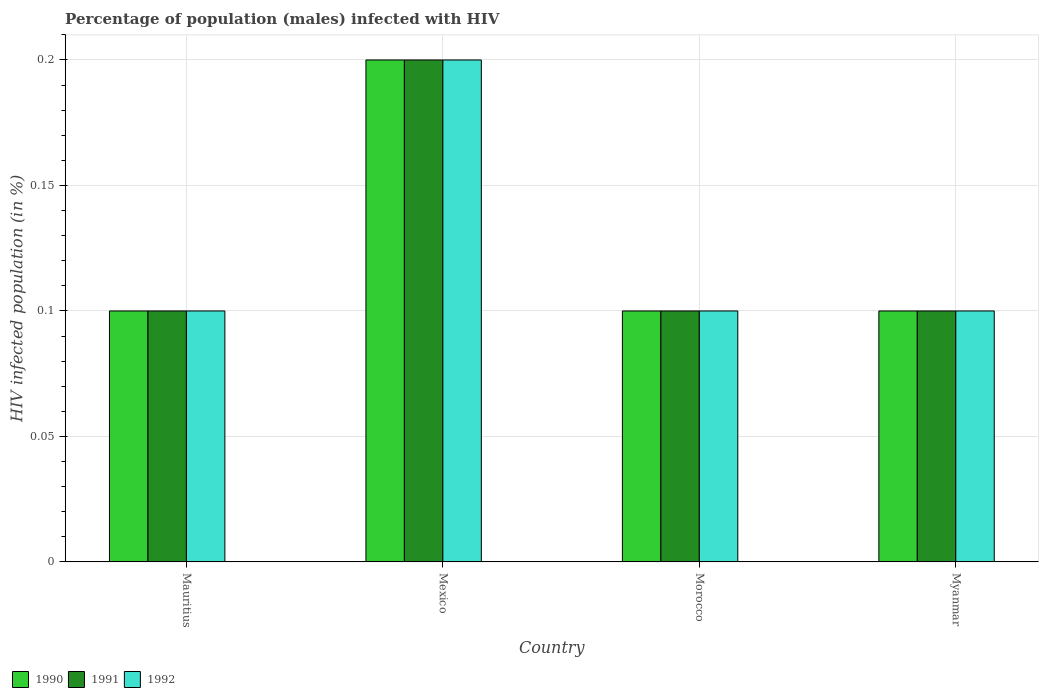How many different coloured bars are there?
Offer a very short reply. 3. How many groups of bars are there?
Keep it short and to the point. 4. Are the number of bars per tick equal to the number of legend labels?
Provide a succinct answer. Yes. How many bars are there on the 2nd tick from the left?
Make the answer very short. 3. How many bars are there on the 2nd tick from the right?
Your response must be concise. 3. What is the label of the 1st group of bars from the left?
Your response must be concise. Mauritius. In which country was the percentage of HIV infected male population in 1992 maximum?
Your response must be concise. Mexico. In which country was the percentage of HIV infected male population in 1990 minimum?
Your answer should be compact. Mauritius. Is the difference between the percentage of HIV infected male population in 1992 in Mauritius and Morocco greater than the difference between the percentage of HIV infected male population in 1991 in Mauritius and Morocco?
Make the answer very short. No. What is the difference between the highest and the second highest percentage of HIV infected male population in 1992?
Ensure brevity in your answer.  0.1. What is the difference between the highest and the lowest percentage of HIV infected male population in 1991?
Your response must be concise. 0.1. Is the sum of the percentage of HIV infected male population in 1990 in Mauritius and Morocco greater than the maximum percentage of HIV infected male population in 1992 across all countries?
Your answer should be very brief. No. What does the 3rd bar from the right in Mauritius represents?
Offer a very short reply. 1990. Is it the case that in every country, the sum of the percentage of HIV infected male population in 1991 and percentage of HIV infected male population in 1990 is greater than the percentage of HIV infected male population in 1992?
Provide a short and direct response. Yes. How many bars are there?
Provide a succinct answer. 12. Are the values on the major ticks of Y-axis written in scientific E-notation?
Provide a succinct answer. No. Does the graph contain grids?
Provide a succinct answer. Yes. How are the legend labels stacked?
Your answer should be compact. Horizontal. What is the title of the graph?
Ensure brevity in your answer.  Percentage of population (males) infected with HIV. Does "2010" appear as one of the legend labels in the graph?
Give a very brief answer. No. What is the label or title of the X-axis?
Your answer should be compact. Country. What is the label or title of the Y-axis?
Your answer should be very brief. HIV infected population (in %). What is the HIV infected population (in %) in 1990 in Mauritius?
Give a very brief answer. 0.1. What is the HIV infected population (in %) in 1991 in Mauritius?
Your answer should be compact. 0.1. What is the HIV infected population (in %) of 1992 in Mauritius?
Offer a terse response. 0.1. What is the HIV infected population (in %) of 1991 in Mexico?
Ensure brevity in your answer.  0.2. What is the HIV infected population (in %) in 1992 in Mexico?
Provide a succinct answer. 0.2. What is the HIV infected population (in %) of 1992 in Morocco?
Make the answer very short. 0.1. What is the HIV infected population (in %) of 1990 in Myanmar?
Offer a very short reply. 0.1. Across all countries, what is the minimum HIV infected population (in %) in 1990?
Make the answer very short. 0.1. Across all countries, what is the minimum HIV infected population (in %) in 1991?
Your answer should be very brief. 0.1. Across all countries, what is the minimum HIV infected population (in %) of 1992?
Provide a short and direct response. 0.1. What is the total HIV infected population (in %) of 1992 in the graph?
Provide a short and direct response. 0.5. What is the difference between the HIV infected population (in %) of 1991 in Mauritius and that in Mexico?
Your response must be concise. -0.1. What is the difference between the HIV infected population (in %) in 1992 in Mauritius and that in Morocco?
Your response must be concise. 0. What is the difference between the HIV infected population (in %) of 1990 in Mexico and that in Morocco?
Your answer should be compact. 0.1. What is the difference between the HIV infected population (in %) of 1992 in Mexico and that in Morocco?
Offer a terse response. 0.1. What is the difference between the HIV infected population (in %) in 1990 in Mexico and that in Myanmar?
Your response must be concise. 0.1. What is the difference between the HIV infected population (in %) in 1991 in Mexico and that in Myanmar?
Provide a succinct answer. 0.1. What is the difference between the HIV infected population (in %) of 1992 in Mexico and that in Myanmar?
Provide a succinct answer. 0.1. What is the difference between the HIV infected population (in %) of 1991 in Morocco and that in Myanmar?
Ensure brevity in your answer.  0. What is the difference between the HIV infected population (in %) of 1992 in Morocco and that in Myanmar?
Ensure brevity in your answer.  0. What is the difference between the HIV infected population (in %) in 1990 in Mauritius and the HIV infected population (in %) in 1992 in Mexico?
Make the answer very short. -0.1. What is the difference between the HIV infected population (in %) in 1990 in Mauritius and the HIV infected population (in %) in 1991 in Morocco?
Offer a terse response. 0. What is the difference between the HIV infected population (in %) in 1991 in Mauritius and the HIV infected population (in %) in 1992 in Morocco?
Offer a very short reply. 0. What is the difference between the HIV infected population (in %) of 1990 in Mauritius and the HIV infected population (in %) of 1992 in Myanmar?
Your answer should be very brief. 0. What is the difference between the HIV infected population (in %) of 1991 in Mauritius and the HIV infected population (in %) of 1992 in Myanmar?
Ensure brevity in your answer.  0. What is the difference between the HIV infected population (in %) in 1990 in Mexico and the HIV infected population (in %) in 1991 in Morocco?
Offer a very short reply. 0.1. What is the difference between the HIV infected population (in %) of 1990 in Mexico and the HIV infected population (in %) of 1992 in Morocco?
Give a very brief answer. 0.1. What is the difference between the HIV infected population (in %) of 1990 in Morocco and the HIV infected population (in %) of 1992 in Myanmar?
Keep it short and to the point. 0. What is the difference between the HIV infected population (in %) in 1991 in Morocco and the HIV infected population (in %) in 1992 in Myanmar?
Provide a short and direct response. 0. What is the average HIV infected population (in %) in 1990 per country?
Your answer should be compact. 0.12. What is the average HIV infected population (in %) in 1991 per country?
Your answer should be very brief. 0.12. What is the average HIV infected population (in %) in 1992 per country?
Your answer should be compact. 0.12. What is the difference between the HIV infected population (in %) of 1990 and HIV infected population (in %) of 1991 in Mauritius?
Provide a short and direct response. 0. What is the difference between the HIV infected population (in %) of 1990 and HIV infected population (in %) of 1992 in Mauritius?
Offer a very short reply. 0. What is the difference between the HIV infected population (in %) in 1991 and HIV infected population (in %) in 1992 in Mauritius?
Your response must be concise. 0. What is the difference between the HIV infected population (in %) of 1990 and HIV infected population (in %) of 1991 in Mexico?
Your response must be concise. 0. What is the difference between the HIV infected population (in %) of 1990 and HIV infected population (in %) of 1992 in Morocco?
Make the answer very short. 0. What is the difference between the HIV infected population (in %) of 1991 and HIV infected population (in %) of 1992 in Morocco?
Keep it short and to the point. 0. What is the ratio of the HIV infected population (in %) of 1990 in Mauritius to that in Mexico?
Give a very brief answer. 0.5. What is the ratio of the HIV infected population (in %) of 1992 in Mauritius to that in Mexico?
Your answer should be very brief. 0.5. What is the ratio of the HIV infected population (in %) in 1991 in Mauritius to that in Morocco?
Make the answer very short. 1. What is the ratio of the HIV infected population (in %) of 1990 in Mauritius to that in Myanmar?
Provide a succinct answer. 1. What is the ratio of the HIV infected population (in %) in 1991 in Mauritius to that in Myanmar?
Offer a very short reply. 1. What is the ratio of the HIV infected population (in %) of 1992 in Mauritius to that in Myanmar?
Make the answer very short. 1. What is the ratio of the HIV infected population (in %) in 1990 in Mexico to that in Morocco?
Provide a succinct answer. 2. What is the ratio of the HIV infected population (in %) in 1991 in Mexico to that in Morocco?
Your answer should be very brief. 2. What is the ratio of the HIV infected population (in %) in 1991 in Mexico to that in Myanmar?
Your answer should be compact. 2. What is the ratio of the HIV infected population (in %) in 1992 in Mexico to that in Myanmar?
Ensure brevity in your answer.  2. What is the ratio of the HIV infected population (in %) in 1990 in Morocco to that in Myanmar?
Your response must be concise. 1. What is the ratio of the HIV infected population (in %) in 1992 in Morocco to that in Myanmar?
Offer a terse response. 1. What is the difference between the highest and the second highest HIV infected population (in %) of 1991?
Offer a very short reply. 0.1. What is the difference between the highest and the second highest HIV infected population (in %) in 1992?
Make the answer very short. 0.1. What is the difference between the highest and the lowest HIV infected population (in %) in 1990?
Give a very brief answer. 0.1. What is the difference between the highest and the lowest HIV infected population (in %) in 1992?
Provide a succinct answer. 0.1. 